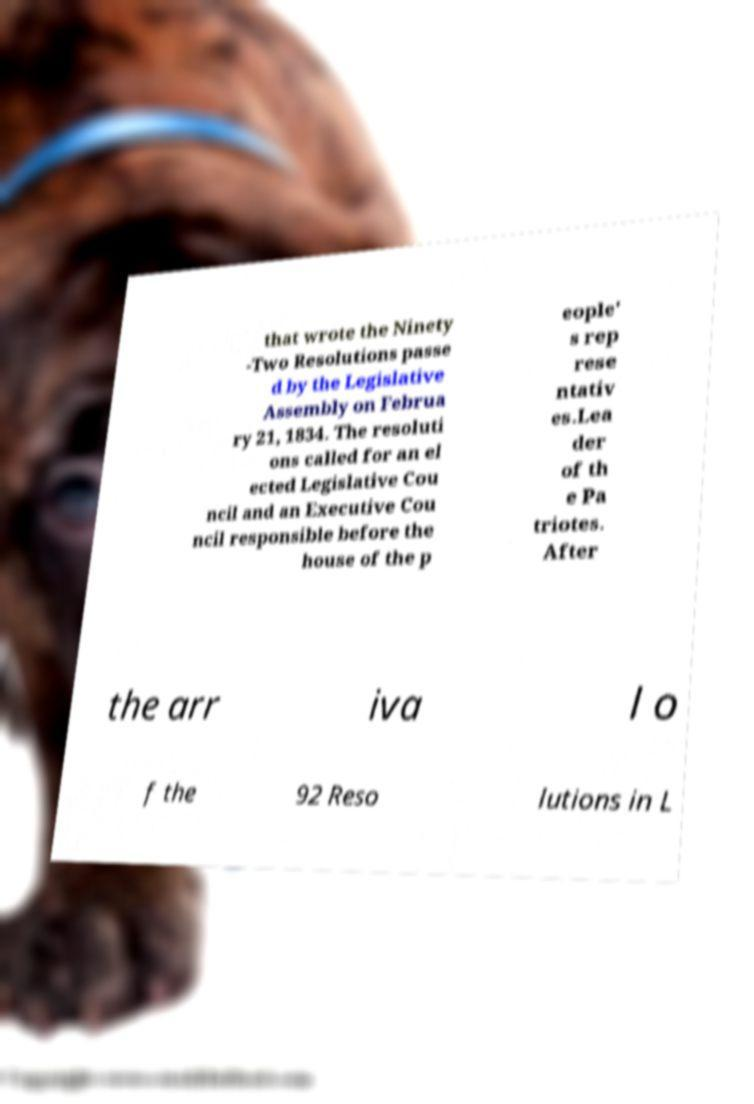There's text embedded in this image that I need extracted. Can you transcribe it verbatim? that wrote the Ninety -Two Resolutions passe d by the Legislative Assembly on Februa ry 21, 1834. The resoluti ons called for an el ected Legislative Cou ncil and an Executive Cou ncil responsible before the house of the p eople' s rep rese ntativ es.Lea der of th e Pa triotes. After the arr iva l o f the 92 Reso lutions in L 